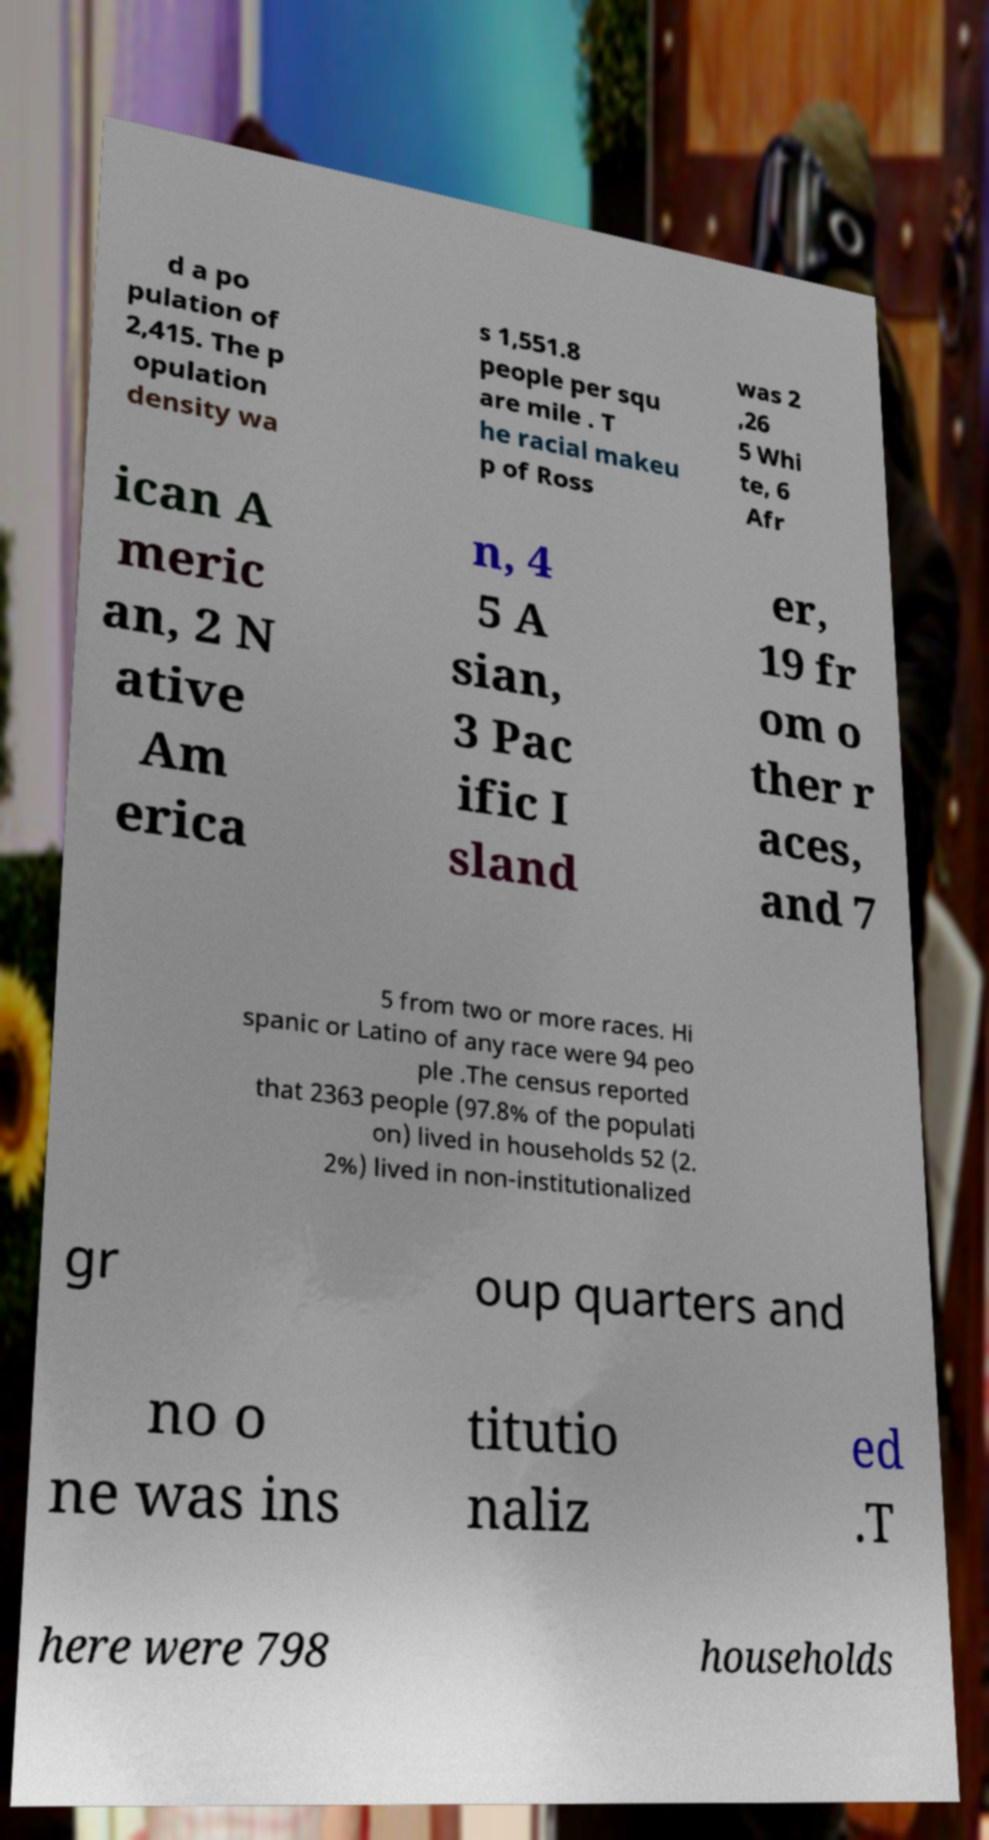Can you read and provide the text displayed in the image?This photo seems to have some interesting text. Can you extract and type it out for me? d a po pulation of 2,415. The p opulation density wa s 1,551.8 people per squ are mile . T he racial makeu p of Ross was 2 ,26 5 Whi te, 6 Afr ican A meric an, 2 N ative Am erica n, 4 5 A sian, 3 Pac ific I sland er, 19 fr om o ther r aces, and 7 5 from two or more races. Hi spanic or Latino of any race were 94 peo ple .The census reported that 2363 people (97.8% of the populati on) lived in households 52 (2. 2%) lived in non-institutionalized gr oup quarters and no o ne was ins titutio naliz ed .T here were 798 households 